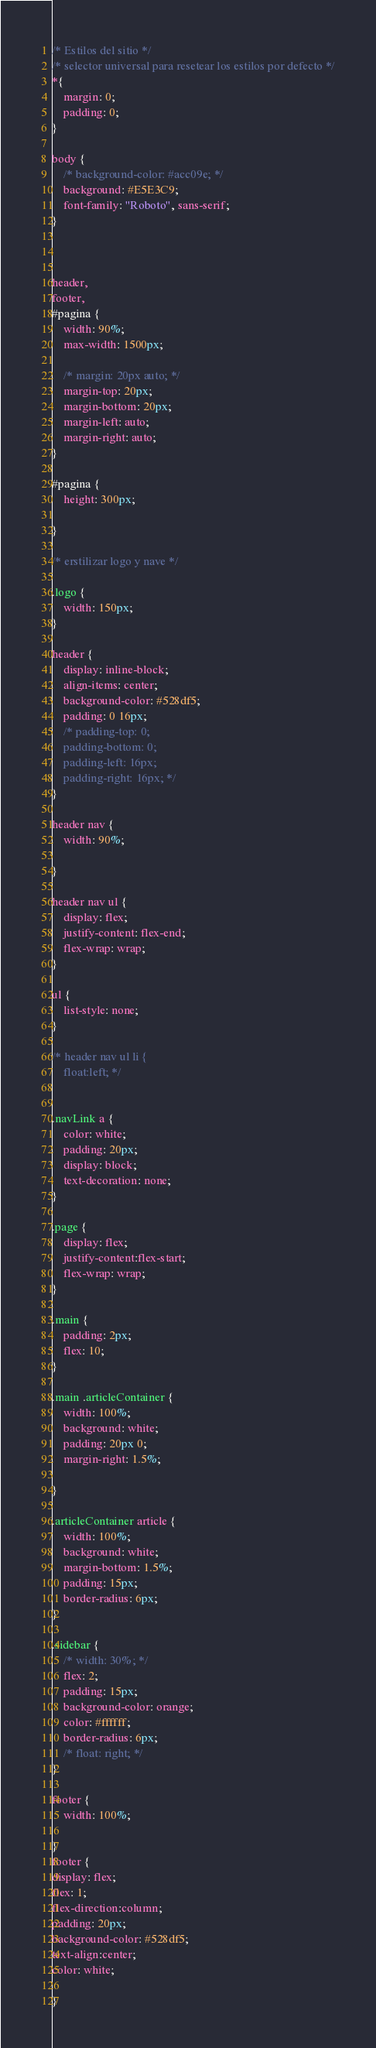Convert code to text. <code><loc_0><loc_0><loc_500><loc_500><_CSS_>/* Estilos del sitio */
/* selector universal para resetear los estilos por defecto */
*{
    margin: 0;
    padding: 0;
}

body {
    /* background-color: #acc09e; */
    background: #E5E3C9;
    font-family: "Roboto", sans-serif;
}


 
header, 
footer, 
#pagina {
    width: 90%;
    max-width: 1500px;
    
    /* margin: 20px auto; */
    margin-top: 20px;
    margin-bottom: 20px;
    margin-left: auto;
    margin-right: auto;
}

#pagina {
    height: 300px;
    
}

/* erstilizar logo y nave */

.logo {
    width: 150px;
} 

header {
    display: inline-block;
    align-items: center;
    background-color: #528df5;
    padding: 0 16px;
    /* padding-top: 0;
    padding-bottom: 0;
    padding-left: 16px;
    padding-right: 16px; */
}

header nav {
    width: 90%;
        
}

header nav ul {
    display: flex;
    justify-content: flex-end;
    flex-wrap: wrap;
}

ul {
    list-style: none;
}

/* header nav ul li {
    float:left; */


.navLink a {
    color: white;
    padding: 20px;
    display: block;
    text-decoration: none;
}

.page {
    display: flex;
    justify-content:flex-start;
    flex-wrap: wrap;
}

.main {
    padding: 2px;
    flex: 10;
}

.main .articleContainer {
    width: 100%;
    background: white;
    padding: 20px 0;
    margin-right: 1.5%;
    
}

.articleContainer article {
    width: 100%;
    background: white;
    margin-bottom: 1.5%;
    padding: 15px;
    border-radius: 6px;
}

.sidebar {
    /* width: 30%; */
    flex: 2;
    padding: 15px;
    background-color: orange;
    color: #ffffff;
    border-radius: 6px;
    /* float: right; */
}

footer {
    width: 100%;

}
footer { 
display: flex;
flex: 1;    
flex-direction:column;  
padding: 20px;
background-color: #528df5;
text-align:center;
color: white;

}

</code> 